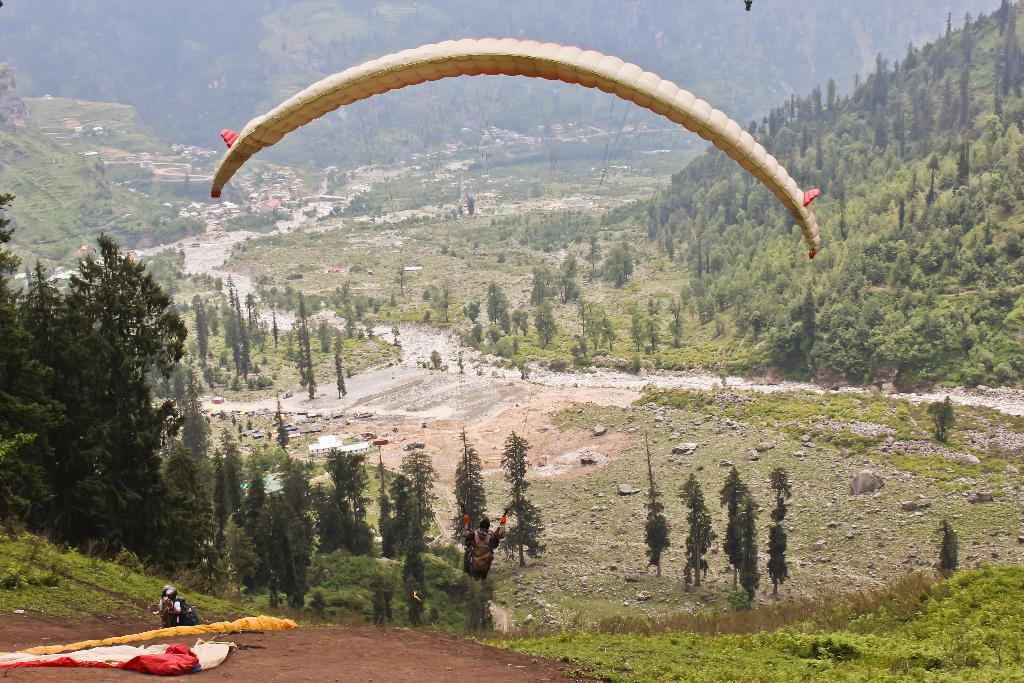How many persons can be seen in the image? There are persons in the image, but the exact number is not specified. What activity is one person engaged in? One person is parachuting with a parachute. What type of structures are visible in the image? There are buildings in the image. What natural elements can be seen in the image? There are trees and hills in the image. What type of religious symbol can be seen on the parachute in the image? There is no religious symbol present on the parachute in the image. How does the comfort level of the persons in the image compare to that of the trees? The comfort level of the persons and trees cannot be compared, as comfort is a subjective feeling and cannot be determined from the image. 